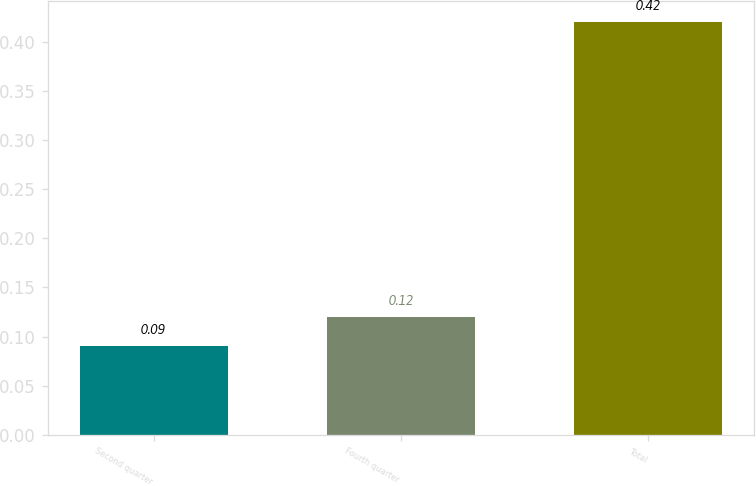<chart> <loc_0><loc_0><loc_500><loc_500><bar_chart><fcel>Second quarter<fcel>Fourth quarter<fcel>Total<nl><fcel>0.09<fcel>0.12<fcel>0.42<nl></chart> 